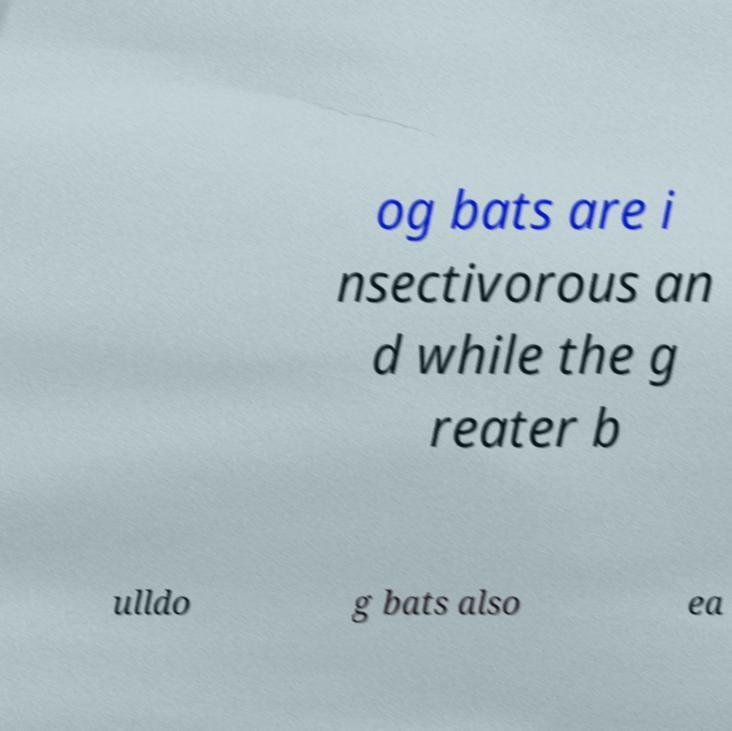I need the written content from this picture converted into text. Can you do that? og bats are i nsectivorous an d while the g reater b ulldo g bats also ea 